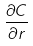Convert formula to latex. <formula><loc_0><loc_0><loc_500><loc_500>\frac { \partial C } { \partial r }</formula> 